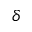<formula> <loc_0><loc_0><loc_500><loc_500>\delta</formula> 